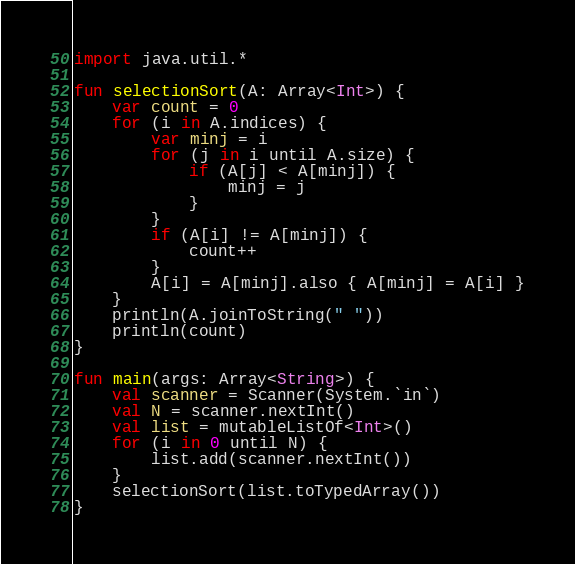<code> <loc_0><loc_0><loc_500><loc_500><_Kotlin_>import java.util.*

fun selectionSort(A: Array<Int>) {
    var count = 0
    for (i in A.indices) {
        var minj = i
        for (j in i until A.size) {
            if (A[j] < A[minj]) {
                minj = j
            }
        }
        if (A[i] != A[minj]) {
            count++
        }
        A[i] = A[minj].also { A[minj] = A[i] }
    }
    println(A.joinToString(" "))
    println(count)
}

fun main(args: Array<String>) {
    val scanner = Scanner(System.`in`)
    val N = scanner.nextInt()
    val list = mutableListOf<Int>()
    for (i in 0 until N) {
        list.add(scanner.nextInt())
    }
    selectionSort(list.toTypedArray())
}
</code> 